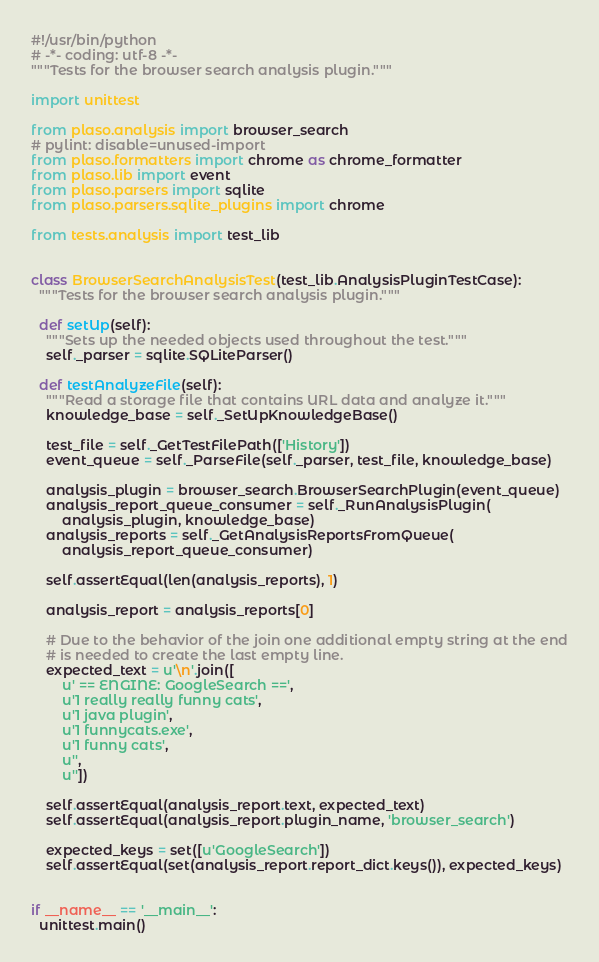<code> <loc_0><loc_0><loc_500><loc_500><_Python_>#!/usr/bin/python
# -*- coding: utf-8 -*-
"""Tests for the browser search analysis plugin."""

import unittest

from plaso.analysis import browser_search
# pylint: disable=unused-import
from plaso.formatters import chrome as chrome_formatter
from plaso.lib import event
from plaso.parsers import sqlite
from plaso.parsers.sqlite_plugins import chrome

from tests.analysis import test_lib


class BrowserSearchAnalysisTest(test_lib.AnalysisPluginTestCase):
  """Tests for the browser search analysis plugin."""

  def setUp(self):
    """Sets up the needed objects used throughout the test."""
    self._parser = sqlite.SQLiteParser()

  def testAnalyzeFile(self):
    """Read a storage file that contains URL data and analyze it."""
    knowledge_base = self._SetUpKnowledgeBase()

    test_file = self._GetTestFilePath(['History'])
    event_queue = self._ParseFile(self._parser, test_file, knowledge_base)

    analysis_plugin = browser_search.BrowserSearchPlugin(event_queue)
    analysis_report_queue_consumer = self._RunAnalysisPlugin(
        analysis_plugin, knowledge_base)
    analysis_reports = self._GetAnalysisReportsFromQueue(
        analysis_report_queue_consumer)

    self.assertEqual(len(analysis_reports), 1)

    analysis_report = analysis_reports[0]

    # Due to the behavior of the join one additional empty string at the end
    # is needed to create the last empty line.
    expected_text = u'\n'.join([
        u' == ENGINE: GoogleSearch ==',
        u'1 really really funny cats',
        u'1 java plugin',
        u'1 funnycats.exe',
        u'1 funny cats',
        u'',
        u''])

    self.assertEqual(analysis_report.text, expected_text)
    self.assertEqual(analysis_report.plugin_name, 'browser_search')

    expected_keys = set([u'GoogleSearch'])
    self.assertEqual(set(analysis_report.report_dict.keys()), expected_keys)


if __name__ == '__main__':
  unittest.main()
</code> 